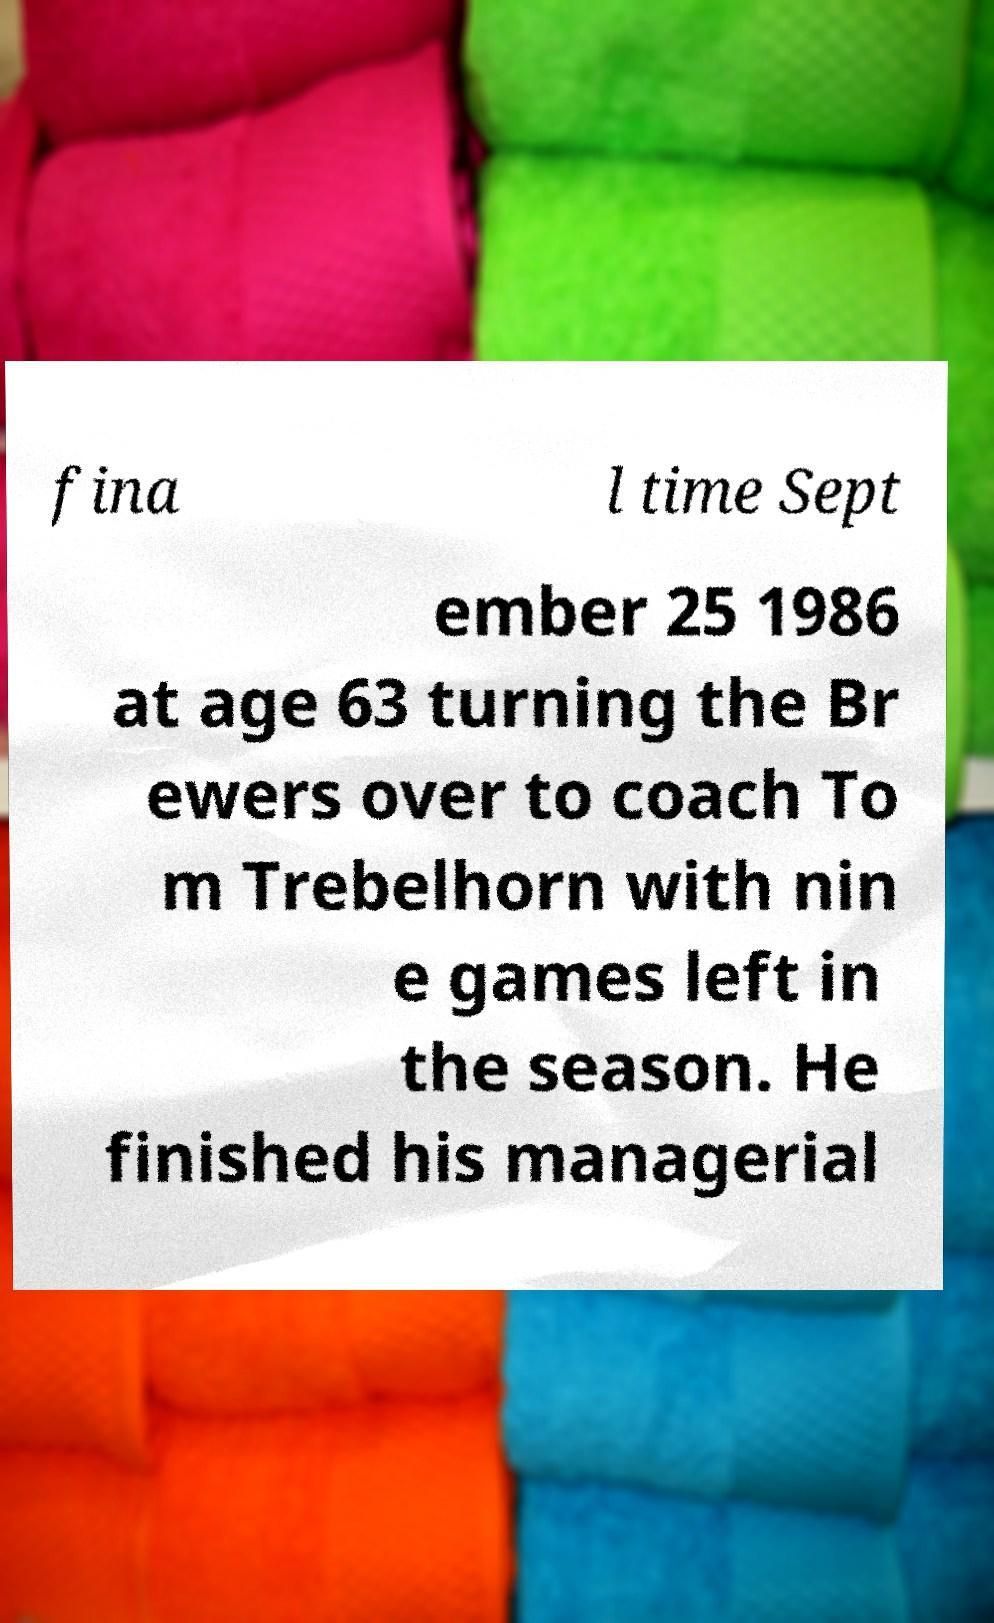What messages or text are displayed in this image? I need them in a readable, typed format. fina l time Sept ember 25 1986 at age 63 turning the Br ewers over to coach To m Trebelhorn with nin e games left in the season. He finished his managerial 